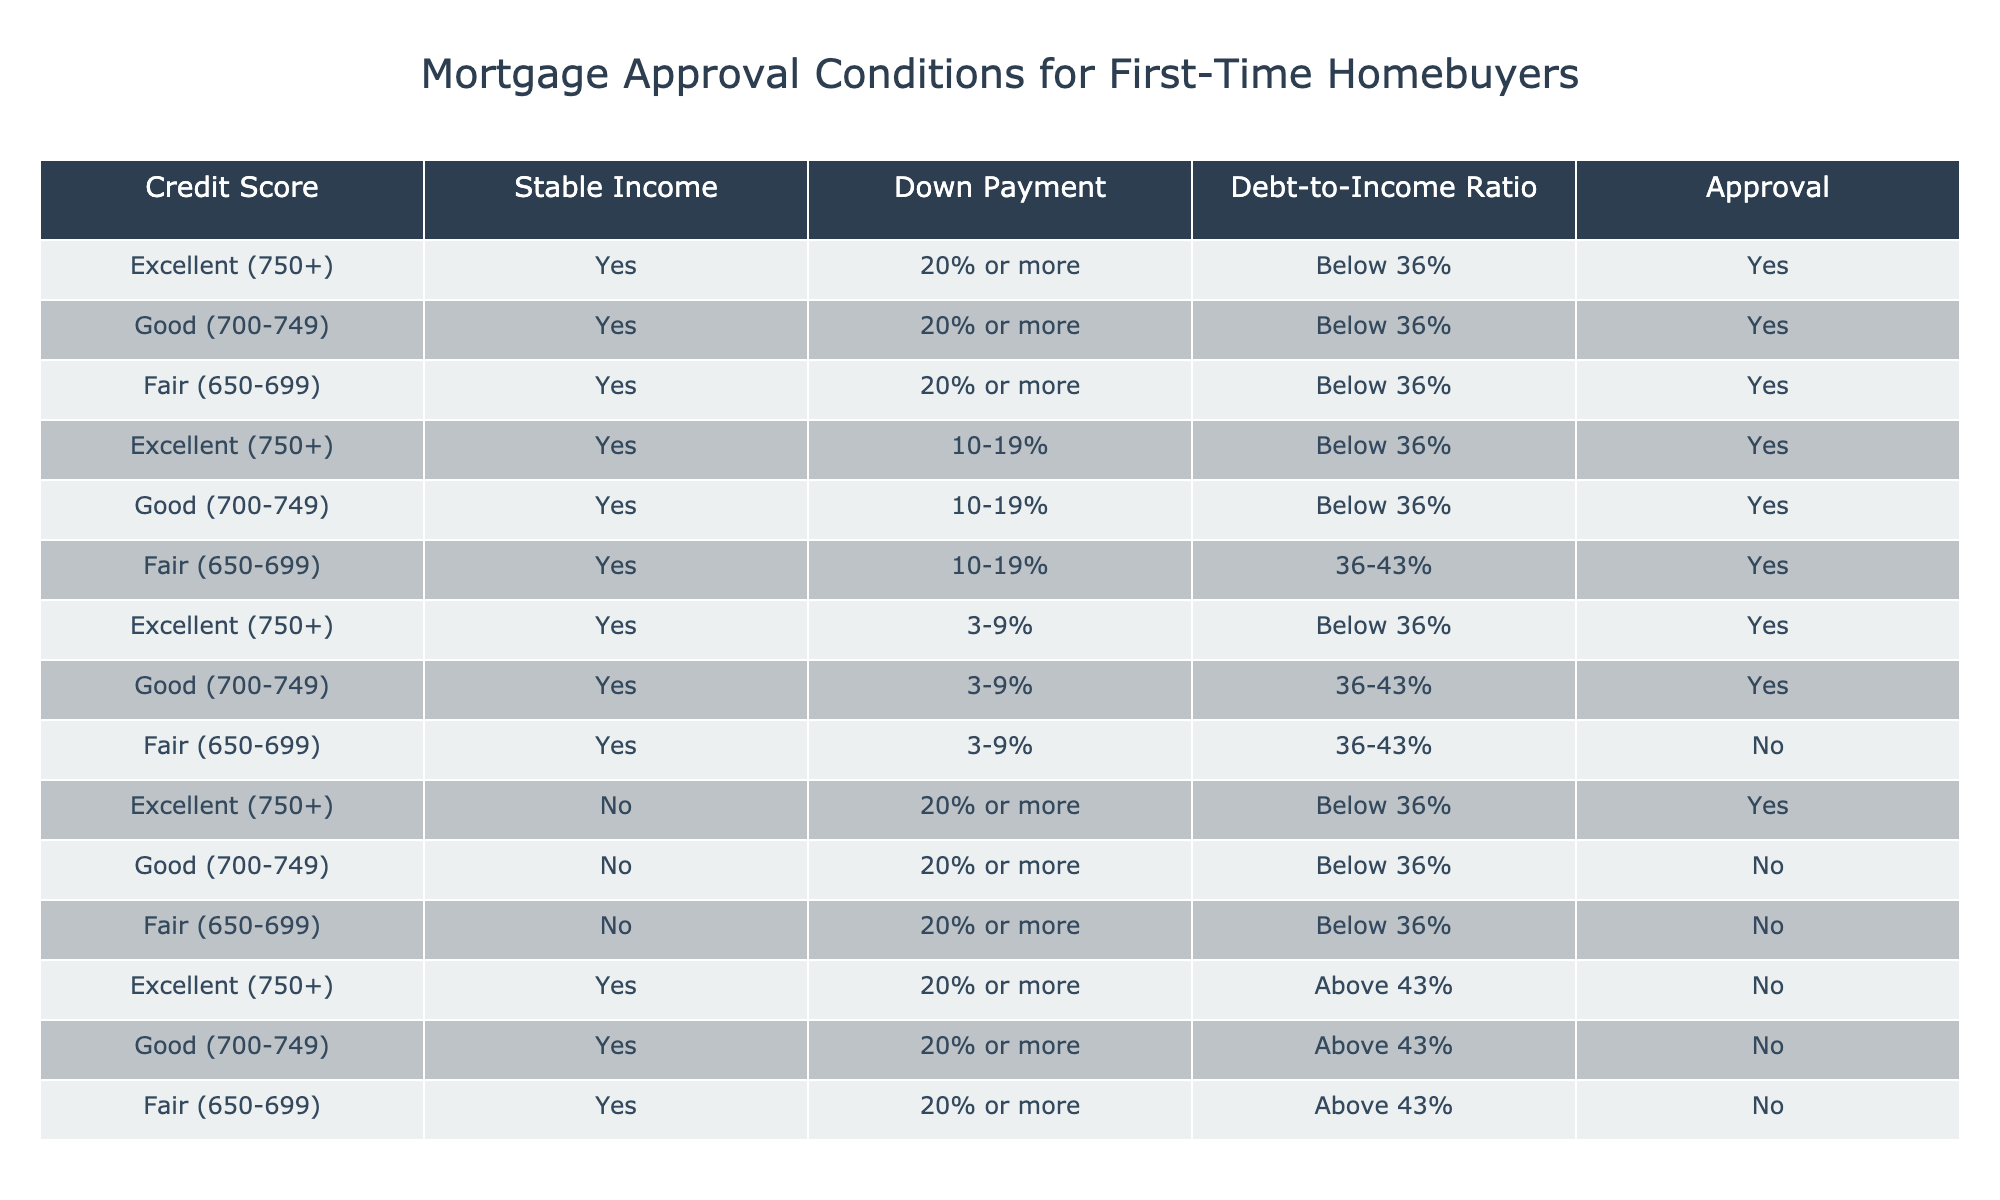What is the maximum down payment percentage among the entries in the table? Upon reviewing the data, the maximum down payment percentage listed is "20% or more". This appears in multiple instances.
Answer: 20% or more How many conditions lead to a "No" approval for Fair credit score with a stable income? Looking at the rows for Fair credit score where the stable income is "Yes," there are two entries: one with a 20% down payment and one with a 10-19% down payment and a debt-to-income ratio of 36-43%. The one with a debt-to-income ratio of 36-43% gets a "No" approval, specifically when the down payment is 3-9%. Therefore, there is only 1 condition that leads to a "No."
Answer: 1 Is it possible for a Good credit score with a down payment below 20% and a debt-to-income ratio above 43% to receive approval? Reviewing the table, there are no entries for Good credit score with a down payment below 20% and a debt-to-income ratio above 43%. This implies that it is impossible for such conditions to exist that lead to an approval.
Answer: No What percentage of approvals are granted to applicants with Excellent credit scores? There are six entries with an "Excellent" credit score in the table, of which four result in "Yes". The total number of entries is 12. Therefore, the calculation is (4/12)*100 = 33.33%.
Answer: 33.33% For a Fair credit score, what conditions can lead to an approval? From the table, a Fair credit score can lead to approvals under two conditions: one with a down payment of 20% or more and a debt-to-income ratio below 36%, and the second with a 10-19% down payment and a debt-to-income ratio below 36%. Thus, the entries clearly indicate two distinct approval paths.
Answer: 2 Are all applicants with Excellent credit scores required to have a down payment of at least 20% in order to receive approval? Analyzing the entries with an "Excellent" credit score, it is clear there are three instances where a lower down payment of 10-19% and 3-9% still results in "Yes" approvals, indicating that having a down payment of 20% is not a requirement.
Answer: No How many conditions lead to an approval when the debt-to-income ratio is "Below 36%"? By examining the table, we see that there are five distinct entries where debt-to-income is categorized as "Below 36%", and each of these leads to an approval: three for Excellent credit scores, one for Good, and one for Fair. Thus, there are five conditions leading to an approval.
Answer: 5 What is the approval outcome for a Good credit score with a 3-9% down payment and a debt-to-income ratio above 43%? Going through the table, there is no entry specifically for a Good credit score with a 3-9% down payment and a debt-to-income ratio above 43%. As such, it would be inferred that this scenario cannot lead to an approval given it doesn’t exist in the data.
Answer: No 